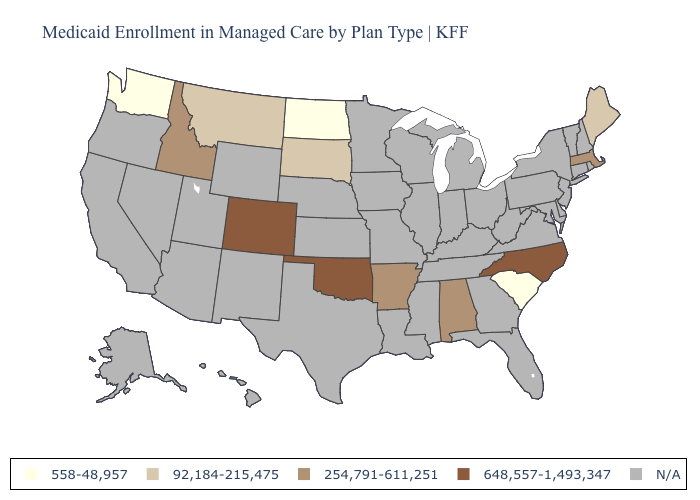Which states have the lowest value in the USA?
Be succinct. North Dakota, South Carolina, Washington. Which states have the lowest value in the West?
Answer briefly. Washington. Does North Dakota have the lowest value in the MidWest?
Give a very brief answer. Yes. What is the value of Alabama?
Quick response, please. 254,791-611,251. Which states have the lowest value in the Northeast?
Quick response, please. Maine. Name the states that have a value in the range N/A?
Be succinct. Alaska, Arizona, California, Connecticut, Delaware, Florida, Georgia, Hawaii, Illinois, Indiana, Iowa, Kansas, Kentucky, Louisiana, Maryland, Michigan, Minnesota, Mississippi, Missouri, Nebraska, Nevada, New Hampshire, New Jersey, New Mexico, New York, Ohio, Oregon, Pennsylvania, Rhode Island, Tennessee, Texas, Utah, Vermont, Virginia, West Virginia, Wisconsin, Wyoming. Name the states that have a value in the range 254,791-611,251?
Be succinct. Alabama, Arkansas, Idaho, Massachusetts. What is the value of New Jersey?
Quick response, please. N/A. What is the value of Oklahoma?
Quick response, please. 648,557-1,493,347. Name the states that have a value in the range 254,791-611,251?
Concise answer only. Alabama, Arkansas, Idaho, Massachusetts. Does Arkansas have the lowest value in the USA?
Be succinct. No. What is the lowest value in the USA?
Answer briefly. 558-48,957. What is the value of Wisconsin?
Give a very brief answer. N/A. 